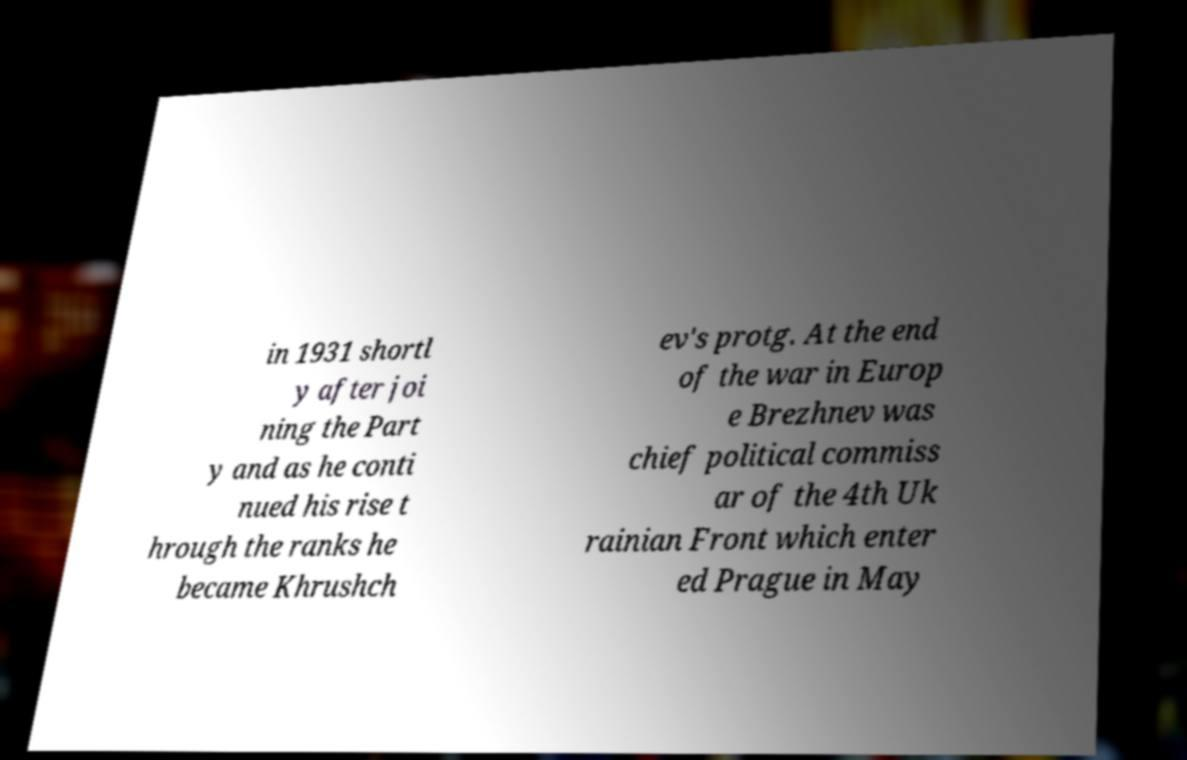Could you assist in decoding the text presented in this image and type it out clearly? in 1931 shortl y after joi ning the Part y and as he conti nued his rise t hrough the ranks he became Khrushch ev's protg. At the end of the war in Europ e Brezhnev was chief political commiss ar of the 4th Uk rainian Front which enter ed Prague in May 